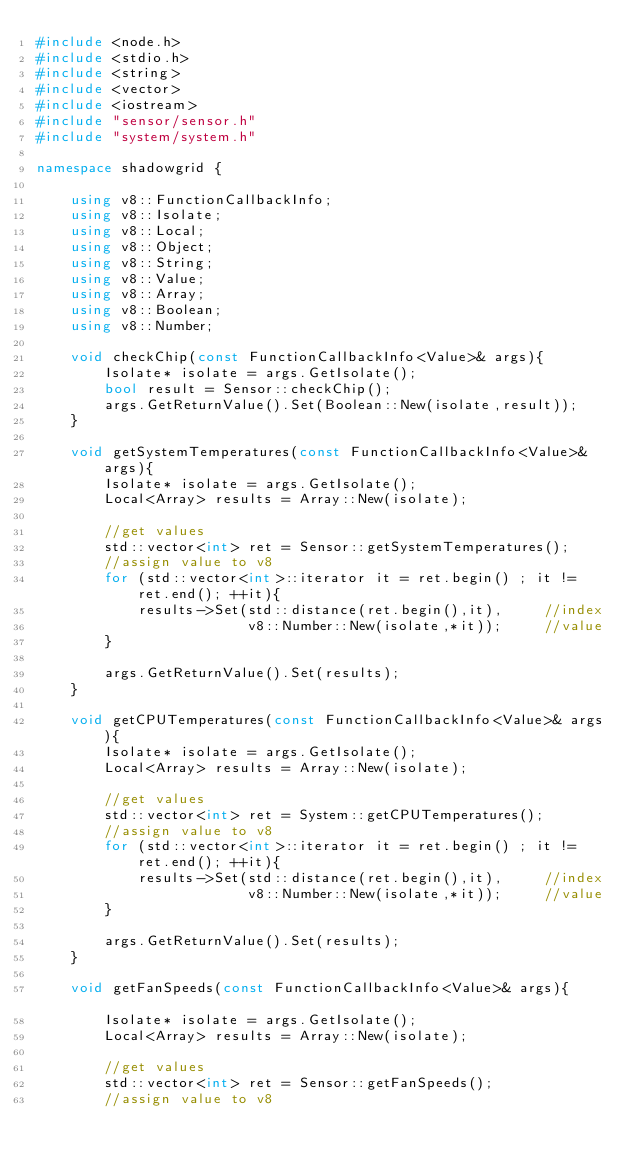Convert code to text. <code><loc_0><loc_0><loc_500><loc_500><_C++_>#include <node.h>
#include <stdio.h>
#include <string>
#include <vector>
#include <iostream>
#include "sensor/sensor.h"
#include "system/system.h"

namespace shadowgrid {

	using v8::FunctionCallbackInfo;
	using v8::Isolate;
	using v8::Local;
	using v8::Object;
	using v8::String;
	using v8::Value;		
	using v8::Array;
	using v8::Boolean;
	using v8::Number;

	void checkChip(const FunctionCallbackInfo<Value>& args){
	  	Isolate* isolate = args.GetIsolate();
	  	bool result = Sensor::checkChip();		
	  	args.GetReturnValue().Set(Boolean::New(isolate,result));
	}

	void getSystemTemperatures(const FunctionCallbackInfo<Value>& args){
		Isolate* isolate = args.GetIsolate();
		Local<Array> results = Array::New(isolate);
		
		//get values
		std::vector<int> ret = Sensor::getSystemTemperatures();
		//assign value to v8 
		for (std::vector<int>::iterator it = ret.begin() ; it != ret.end(); ++it){
			results->Set(std::distance(ret.begin(),it), 	//index
						 v8::Number::New(isolate,*it));		//value
		}

		args.GetReturnValue().Set(results);
	}

	void getCPUTemperatures(const FunctionCallbackInfo<Value>& args){
		Isolate* isolate = args.GetIsolate();
		Local<Array> results = Array::New(isolate);
		
		//get values
		std::vector<int> ret = System::getCPUTemperatures();
		//assign value to v8 
		for (std::vector<int>::iterator it = ret.begin() ; it != ret.end(); ++it){
			results->Set(std::distance(ret.begin(),it), 	//index
						 v8::Number::New(isolate,*it));		//value
		}

		args.GetReturnValue().Set(results);
	}	

	void getFanSpeeds(const FunctionCallbackInfo<Value>& args){				
		Isolate* isolate = args.GetIsolate();
		Local<Array> results = Array::New(isolate);
		
		//get values
		std::vector<int> ret = Sensor::getFanSpeeds();
		//assign value to v8 </code> 